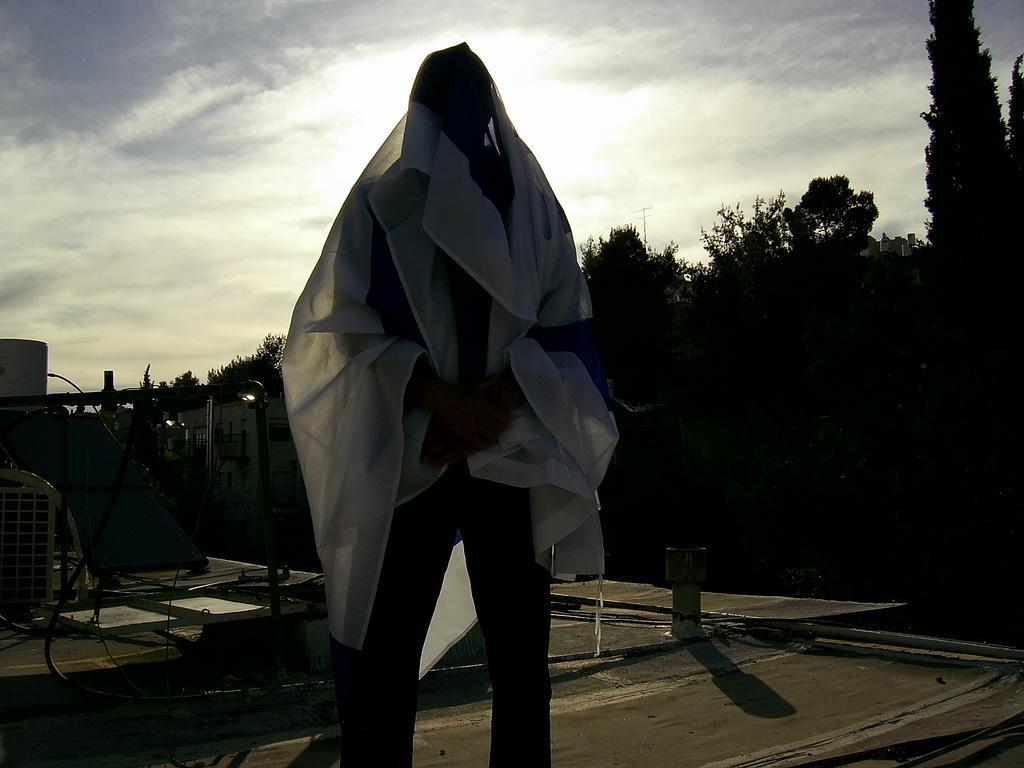In one or two sentences, can you explain what this image depicts? In this picture we can see a person. There is a building behind this person. We can see trees, other objects and the sky. 